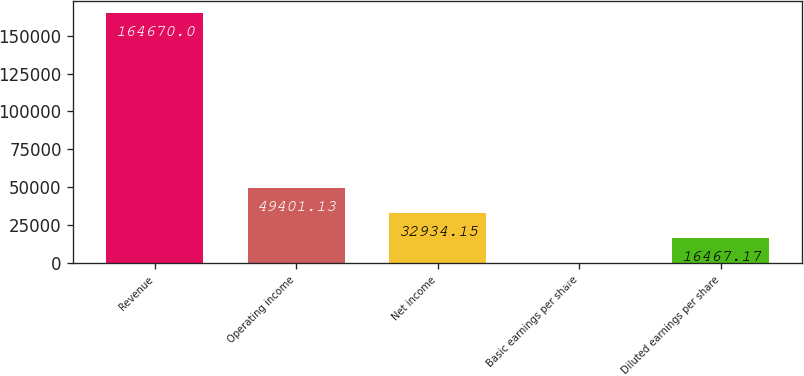Convert chart. <chart><loc_0><loc_0><loc_500><loc_500><bar_chart><fcel>Revenue<fcel>Operating income<fcel>Net income<fcel>Basic earnings per share<fcel>Diluted earnings per share<nl><fcel>164670<fcel>49401.1<fcel>32934.2<fcel>0.19<fcel>16467.2<nl></chart> 